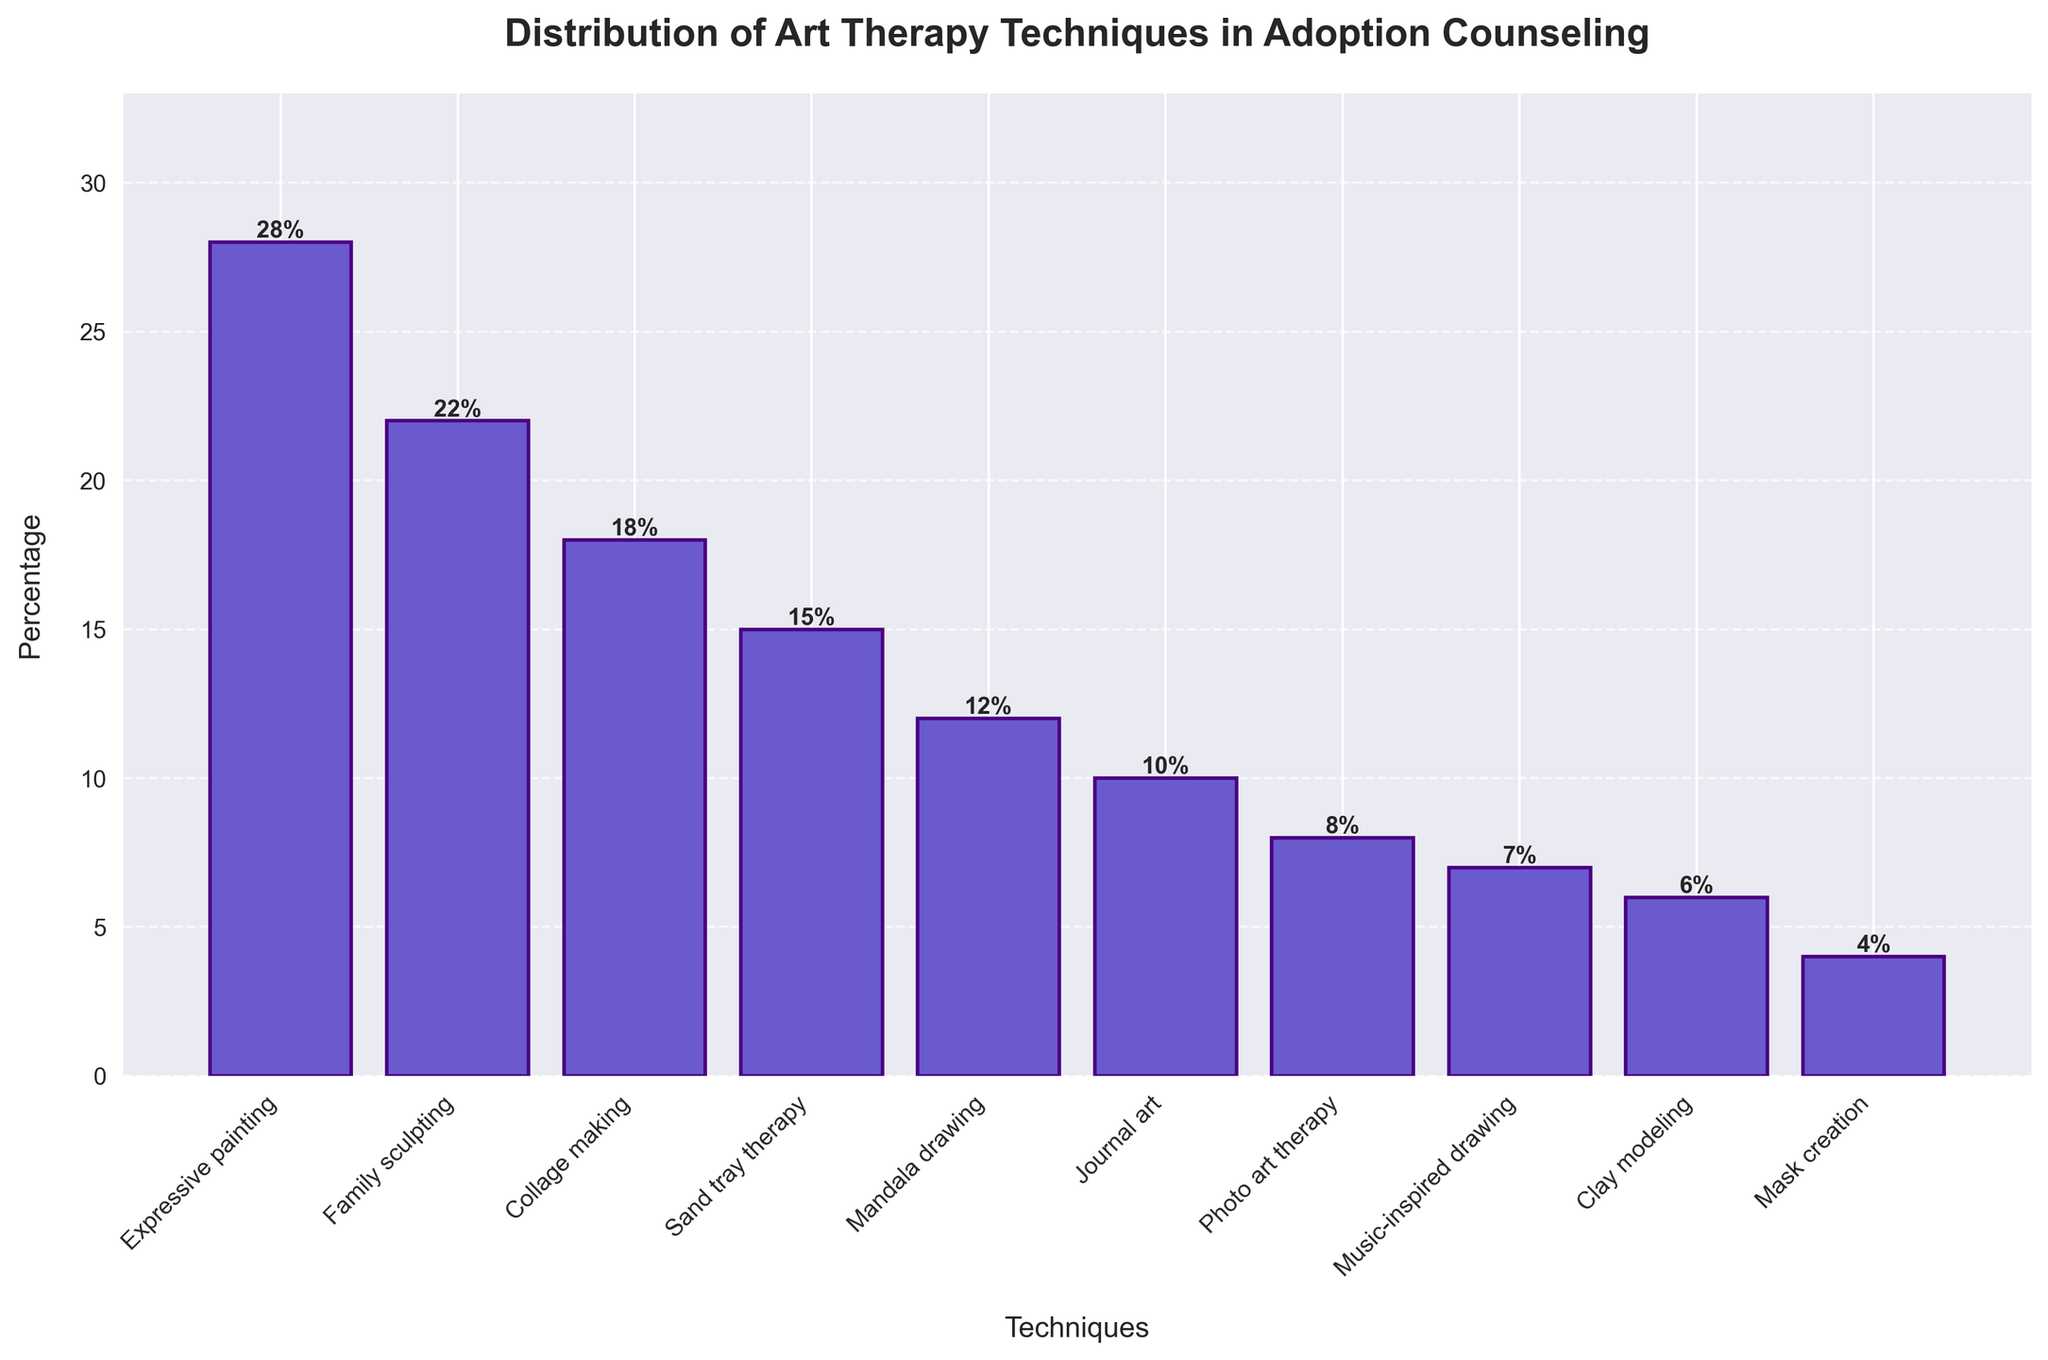Which art therapy technique is the most commonly used in adoption counseling based on the chart? The chart shows the percentages for each technique. The highest bar corresponds to Expressive painting with 28%.
Answer: Expressive painting Which two techniques are the least commonly used according to the bar chart? By observing the heights of the bars, the shortest bars represent Mask creation (4%) and Clay modeling (6%).
Answer: Mask creation and Clay modeling What is the combined percentage for Family sculpting and Collage making? From the chart, Family sculpting is 22% and Collage making is 18%. Adding these together gives 22% + 18% = 40%.
Answer: 40% By how much does Expressive painting exceed Sand tray therapy in percentage? The bar for Expressive painting is at 28%, and for Sand tray therapy, it is at 15%. The difference is 28% - 15% = 13%.
Answer: 13% Which technique has a percentage value that is closer to the average percentage of all techniques shown? To find the average percentage: sum all the percentages (28 + 22 + 18 + 15 + 12 + 10 + 8 + 7 + 6 + 4 = 130), then divide by the number of techniques (10), which gives an average of 13%. The closest percentage value is Sand tray therapy at 15%.
Answer: Sand tray therapy How many techniques are depicted in the chart with less than 10% usage? By examining the chart, the techniques with less than 10% are Journal art (10%), Photo art therapy (8%), Music-inspired drawing (7%), Clay modeling (6%), and Mask creation (4%). Five techniques are less than 10%.
Answer: 5 What is the difference between the highest and lowest percentages in the chart? The highest percentage is for Expressive painting at 28%, and the lowest is Mask creation at 4%. The difference is 28% - 4% = 24%.
Answer: 24% Which technique has a percentage equal to the median value of all techniques? Arrange the percentages in ascending order: 4, 6, 7, 8, 10, 12, 15, 18, 22, 28. The median value (fifth and sixth value's average) is (10 + 12) / 2 = 11%. There is no technique with exactly 11%, but Journal art is the closest with 10%.
Answer: Journal art 